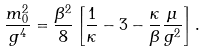Convert formula to latex. <formula><loc_0><loc_0><loc_500><loc_500>\frac { m _ { 0 } ^ { 2 } } { g ^ { 4 } } = \frac { \beta ^ { 2 } } { 8 } \left [ \frac { 1 } { \kappa } - 3 - \frac { \kappa } { \beta } \frac { \mu } { g ^ { 2 } } \right ] .</formula> 